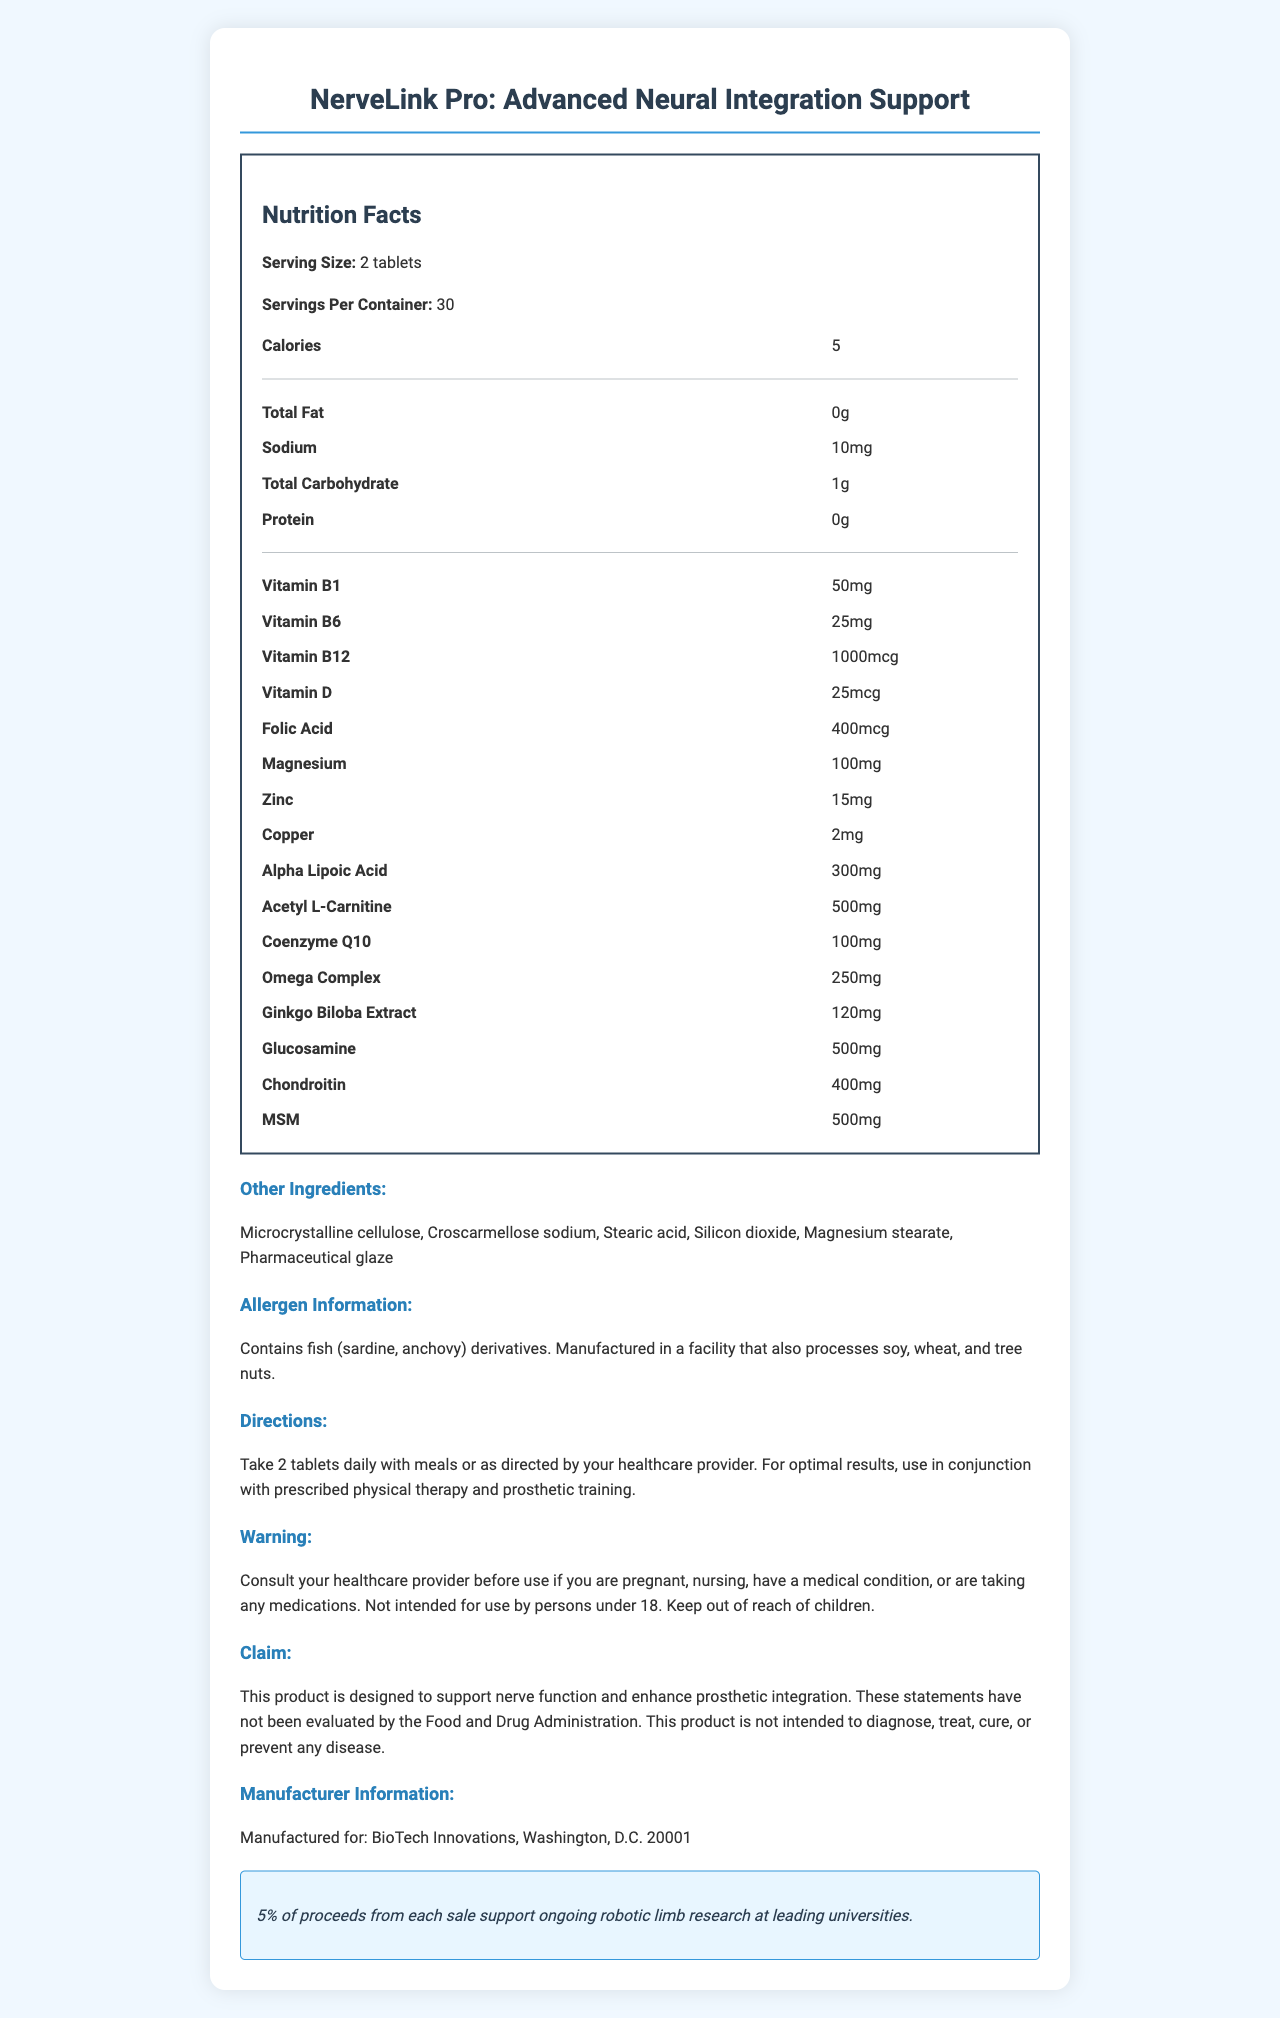what is the serving size? The serving size is mentioned at the beginning of the Nutrition Facts section as "Serving Size: 2 tablets".
Answer: 2 tablets how many calories are in a serving? The number of calories per serving is listed as "Calories: 5" in the Nutrition Facts.
Answer: 5 calories what is the total carbohydrate content per serving? The total carbohydrate content is displayed in the Nutrition Facts as "Total Carbohydrate: 1g".
Answer: 1g how much Vitamin B12 is in each serving? The amount of Vitamin B12 per serving is indicated in the Nutrition Facts as "Vitamin B12: 1000mcg".
Answer: 1000mcg what is listed as the source of the allergen information? The allergen information specifies, "Contains fish (sardine, anchovy) derivatives."
Answer: fish (sardine, anchovy) derivatives which ingredient has the highest amount: Ginkgo Biloba Extract, MSM, or Glucosamine? The amounts listed in the Nutrition Facts are: MSM (500mg), Glucosamine (500mg), and Ginkgo Biloba Extract (120mg). MSM is listed with the highest amount (tie with Glucosamine).
Answer: MSM how often should you take the supplement? The directions state, "Take 2 tablets daily with meals or as directed by your healthcare provider."
Answer: daily which vitamin is present in the smallest amount, as per the document? A. Vitamin B1 B. Vitamin B6 C. Vitamin D The amounts listed are Vitamin B1 (50mg), Vitamin B6 (25mg), and Vitamin D (25mcg), making Vitamin D the smallest in amount.
Answer: C. Vitamin D which mineral is listed with 100mg per serving? The Nutrition Facts section lists Magnesium with an amount of "100mg".
Answer: Magnesium is the product intended for children under 18? The warning statement clearly mentions, "Not intended for use by persons under 18."
Answer: No how much of the proceeds support ongoing robotic limb research? The research funding disclosure states, "5% of proceeds from each sale support ongoing robotic limb research at leading universities."
Answer: 5% summarize the main idea of the document. The document outlines the purpose of NerveLink Pro and its composition, providing a comprehensive look at its nutritional content, usage instructions, and additional relevant information for consumers.
Answer: The document provides detailed information on a specialized vitamin supplement called NerveLink Pro, designed to support nerve function and prosthetic integration. It includes nutrition facts, ingredients, allergen information, directions for use, warnings, manufacturer details, and a fundraising disclosure that supports robotic limb research. what specific impact does ginkgo Biloba Extract have on nerve function and prosthetic integration? The document lists Ginkgo Biloba Extract as an ingredient but does not provide detailed information about its specific impact on nerve function and prosthetic integration.
Answer: Cannot be determined 